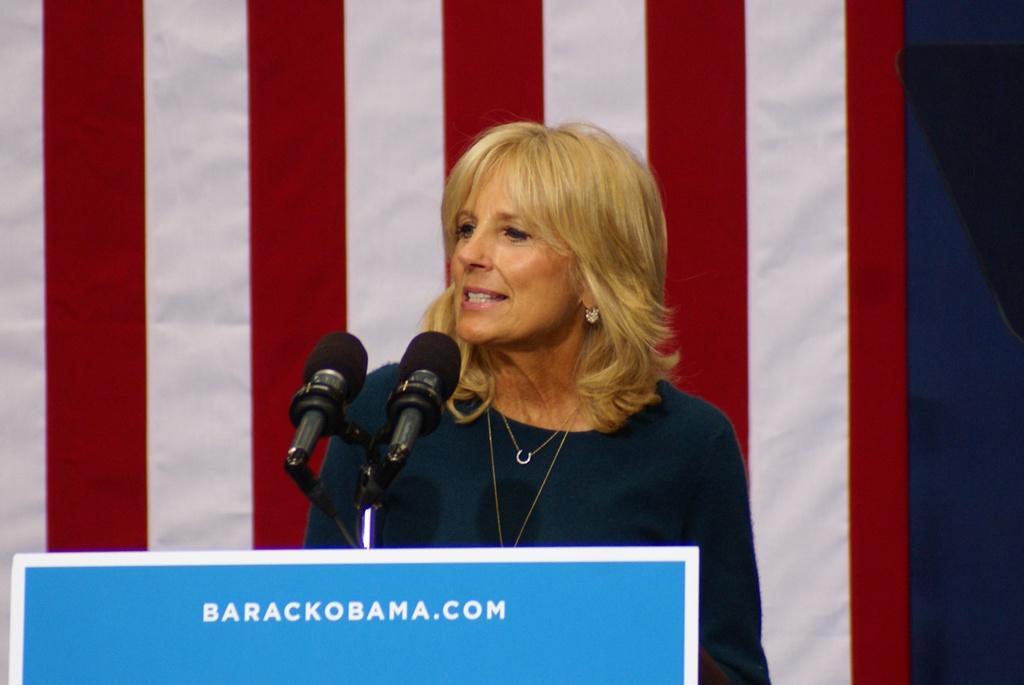In one or two sentences, can you explain what this image depicts? This picture shows a woman standing at a podium and speaking with the help of microphones and we see a flag on the back and we see text on the podium. 